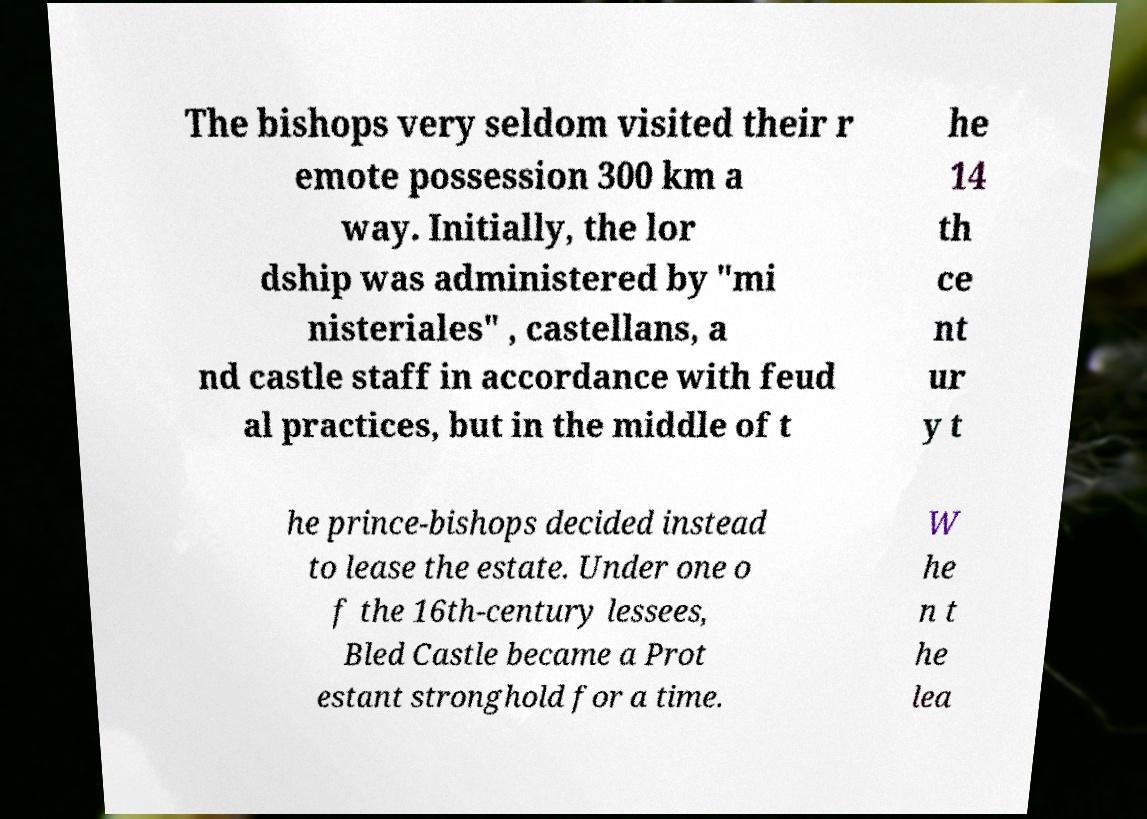Can you read and provide the text displayed in the image?This photo seems to have some interesting text. Can you extract and type it out for me? The bishops very seldom visited their r emote possession 300 km a way. Initially, the lor dship was administered by "mi nisteriales" , castellans, a nd castle staff in accordance with feud al practices, but in the middle of t he 14 th ce nt ur y t he prince-bishops decided instead to lease the estate. Under one o f the 16th-century lessees, Bled Castle became a Prot estant stronghold for a time. W he n t he lea 